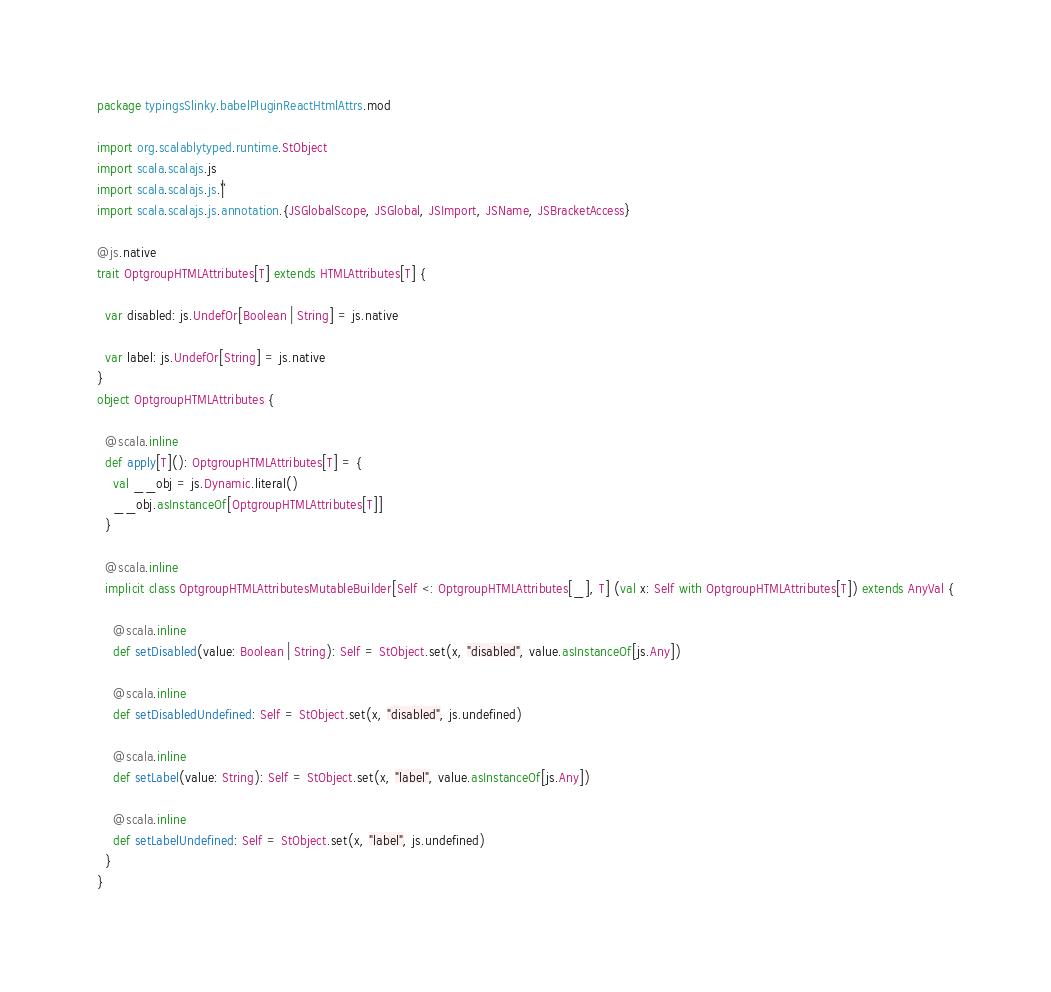<code> <loc_0><loc_0><loc_500><loc_500><_Scala_>package typingsSlinky.babelPluginReactHtmlAttrs.mod

import org.scalablytyped.runtime.StObject
import scala.scalajs.js
import scala.scalajs.js.`|`
import scala.scalajs.js.annotation.{JSGlobalScope, JSGlobal, JSImport, JSName, JSBracketAccess}

@js.native
trait OptgroupHTMLAttributes[T] extends HTMLAttributes[T] {
  
  var disabled: js.UndefOr[Boolean | String] = js.native
  
  var label: js.UndefOr[String] = js.native
}
object OptgroupHTMLAttributes {
  
  @scala.inline
  def apply[T](): OptgroupHTMLAttributes[T] = {
    val __obj = js.Dynamic.literal()
    __obj.asInstanceOf[OptgroupHTMLAttributes[T]]
  }
  
  @scala.inline
  implicit class OptgroupHTMLAttributesMutableBuilder[Self <: OptgroupHTMLAttributes[_], T] (val x: Self with OptgroupHTMLAttributes[T]) extends AnyVal {
    
    @scala.inline
    def setDisabled(value: Boolean | String): Self = StObject.set(x, "disabled", value.asInstanceOf[js.Any])
    
    @scala.inline
    def setDisabledUndefined: Self = StObject.set(x, "disabled", js.undefined)
    
    @scala.inline
    def setLabel(value: String): Self = StObject.set(x, "label", value.asInstanceOf[js.Any])
    
    @scala.inline
    def setLabelUndefined: Self = StObject.set(x, "label", js.undefined)
  }
}
</code> 